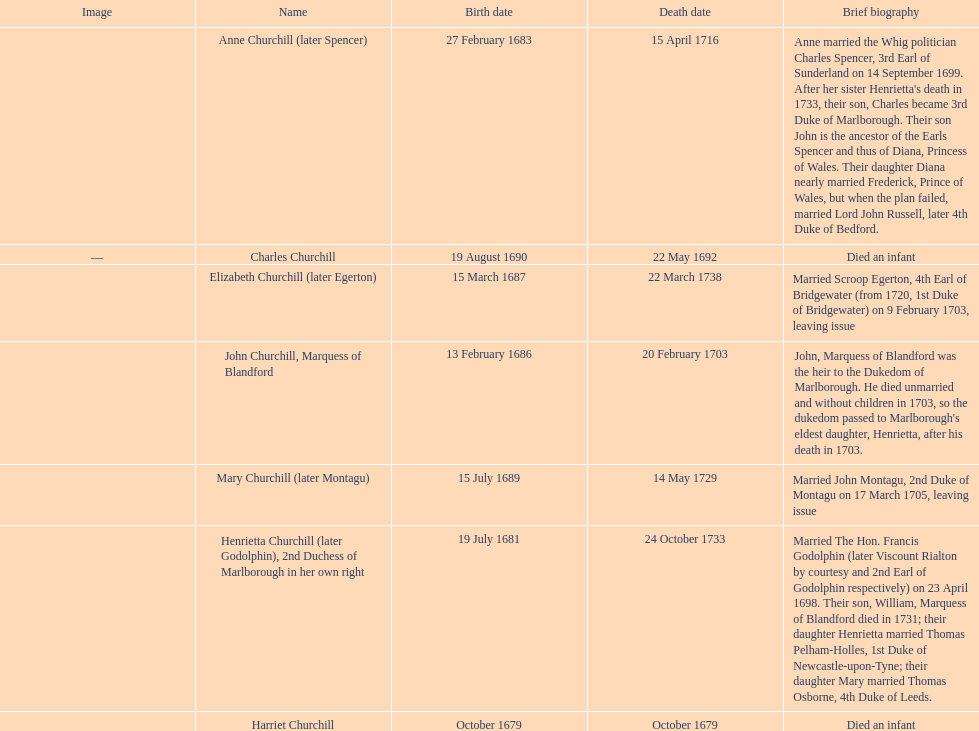What is the total number of children born after 1675? 7. 